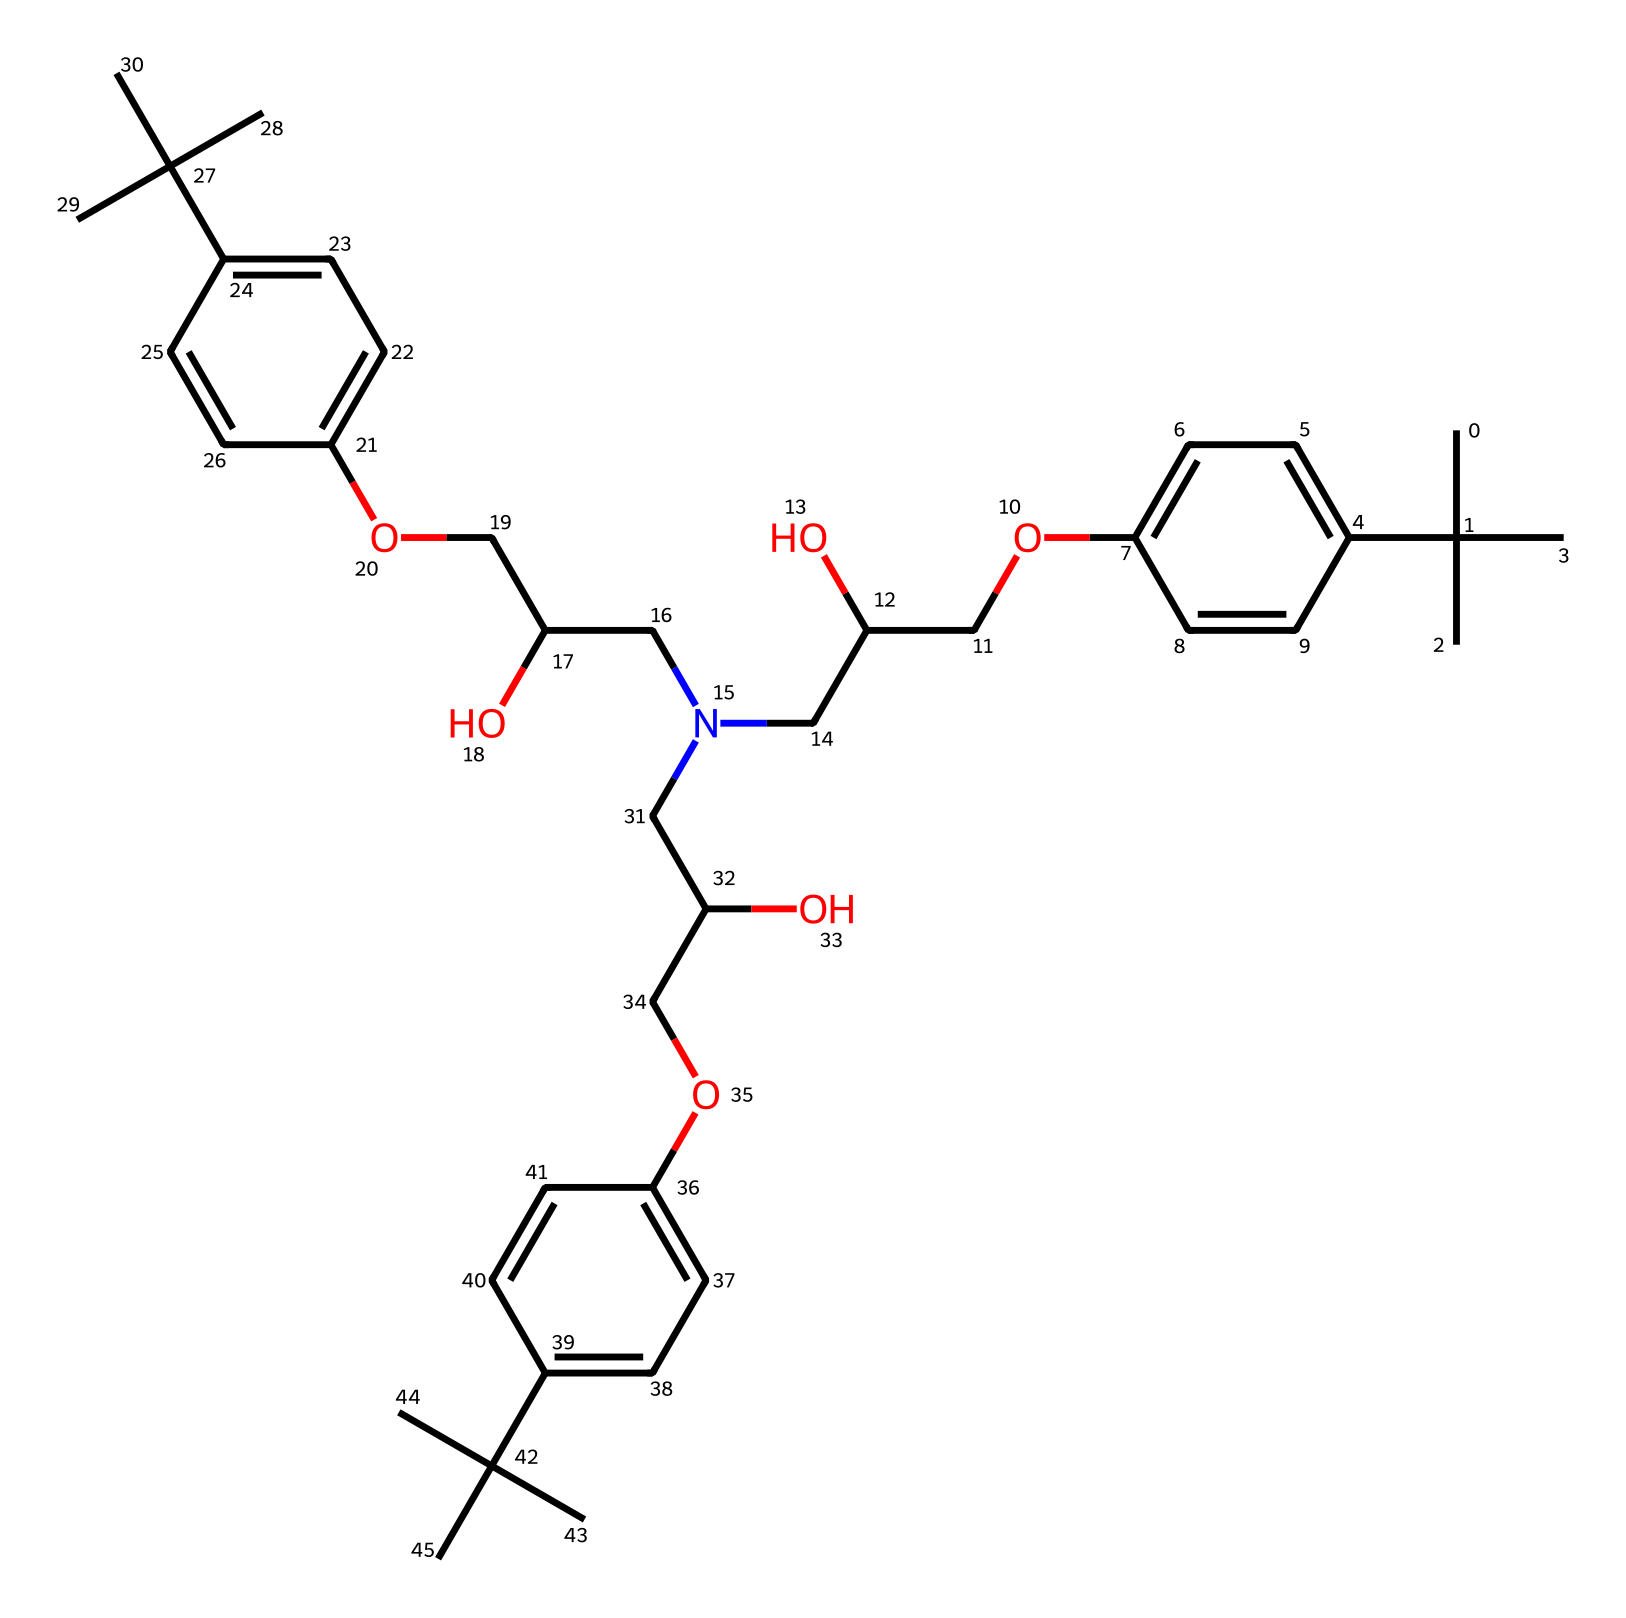What is the primary functional group present in this molecule? The molecule contains multiple hydroxyl (-OH) groups, which are characteristic of alcohols. By examining the SMILES representation, we can note the occurrences of the "O" connected to "C", indicating these functional groups.
Answer: hydroxyl How many carbon atoms are in this chemical structure? Counting the carbons in the provided SMILES, we see multiple "C" notations, including those in branched sections and aromatic rings. A careful count reveals a total of 27 carbon atoms.
Answer: 27 What is the total number of rings present in this molecule? In the SMILES representation, we look for the "c" lower case letters indicating aromatic carbon atoms, which denote rings. Upon inspection, we identify three aromatic rings indicated by the connections in the structure.
Answer: 3 Is this compound likely to be soluble in water? The presence of multiple hydroxyl groups suggests that the molecule is polar and can form hydrogen bonds with water, enhancing its solubility. Therefore, we can infer that it is likely soluble in water due to its functional groups.
Answer: yes What type of chemical compound is represented here? Analyzing the functional groups, particularly the hydroxyl groups, and the presence of large carbon chains indicates that this molecule is indeed classified as a polyol, commonly found in food additives for stability.
Answer: polyol 